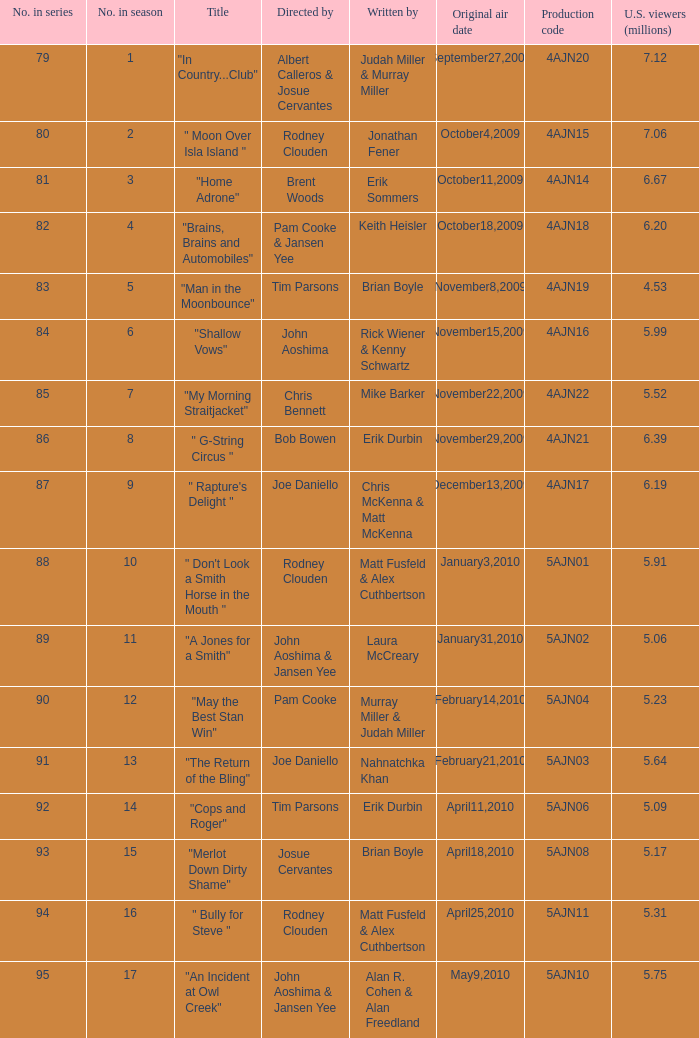Name who wrote 5ajn11 Matt Fusfeld & Alex Cuthbertson. 